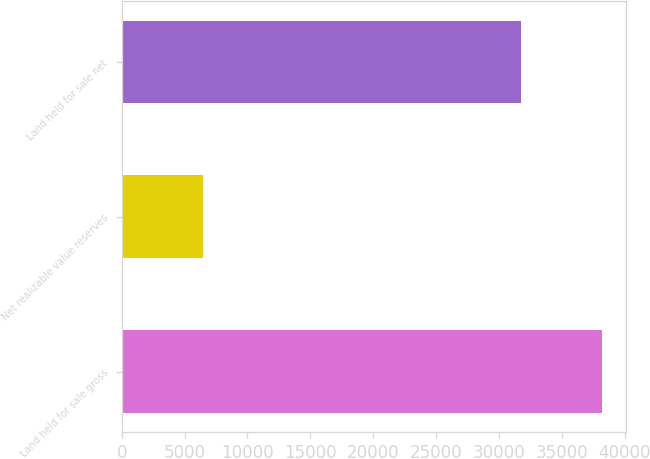Convert chart. <chart><loc_0><loc_0><loc_500><loc_500><bar_chart><fcel>Land held for sale gross<fcel>Net realizable value reserves<fcel>Land held for sale net<nl><fcel>38157<fcel>6429<fcel>31728<nl></chart> 